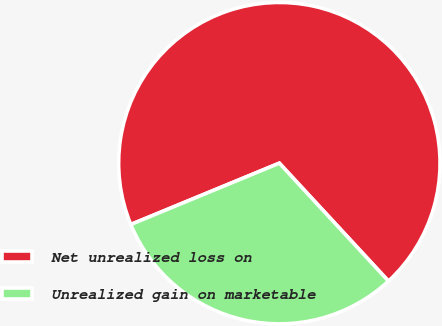<chart> <loc_0><loc_0><loc_500><loc_500><pie_chart><fcel>Net unrealized loss on<fcel>Unrealized gain on marketable<nl><fcel>69.35%<fcel>30.65%<nl></chart> 